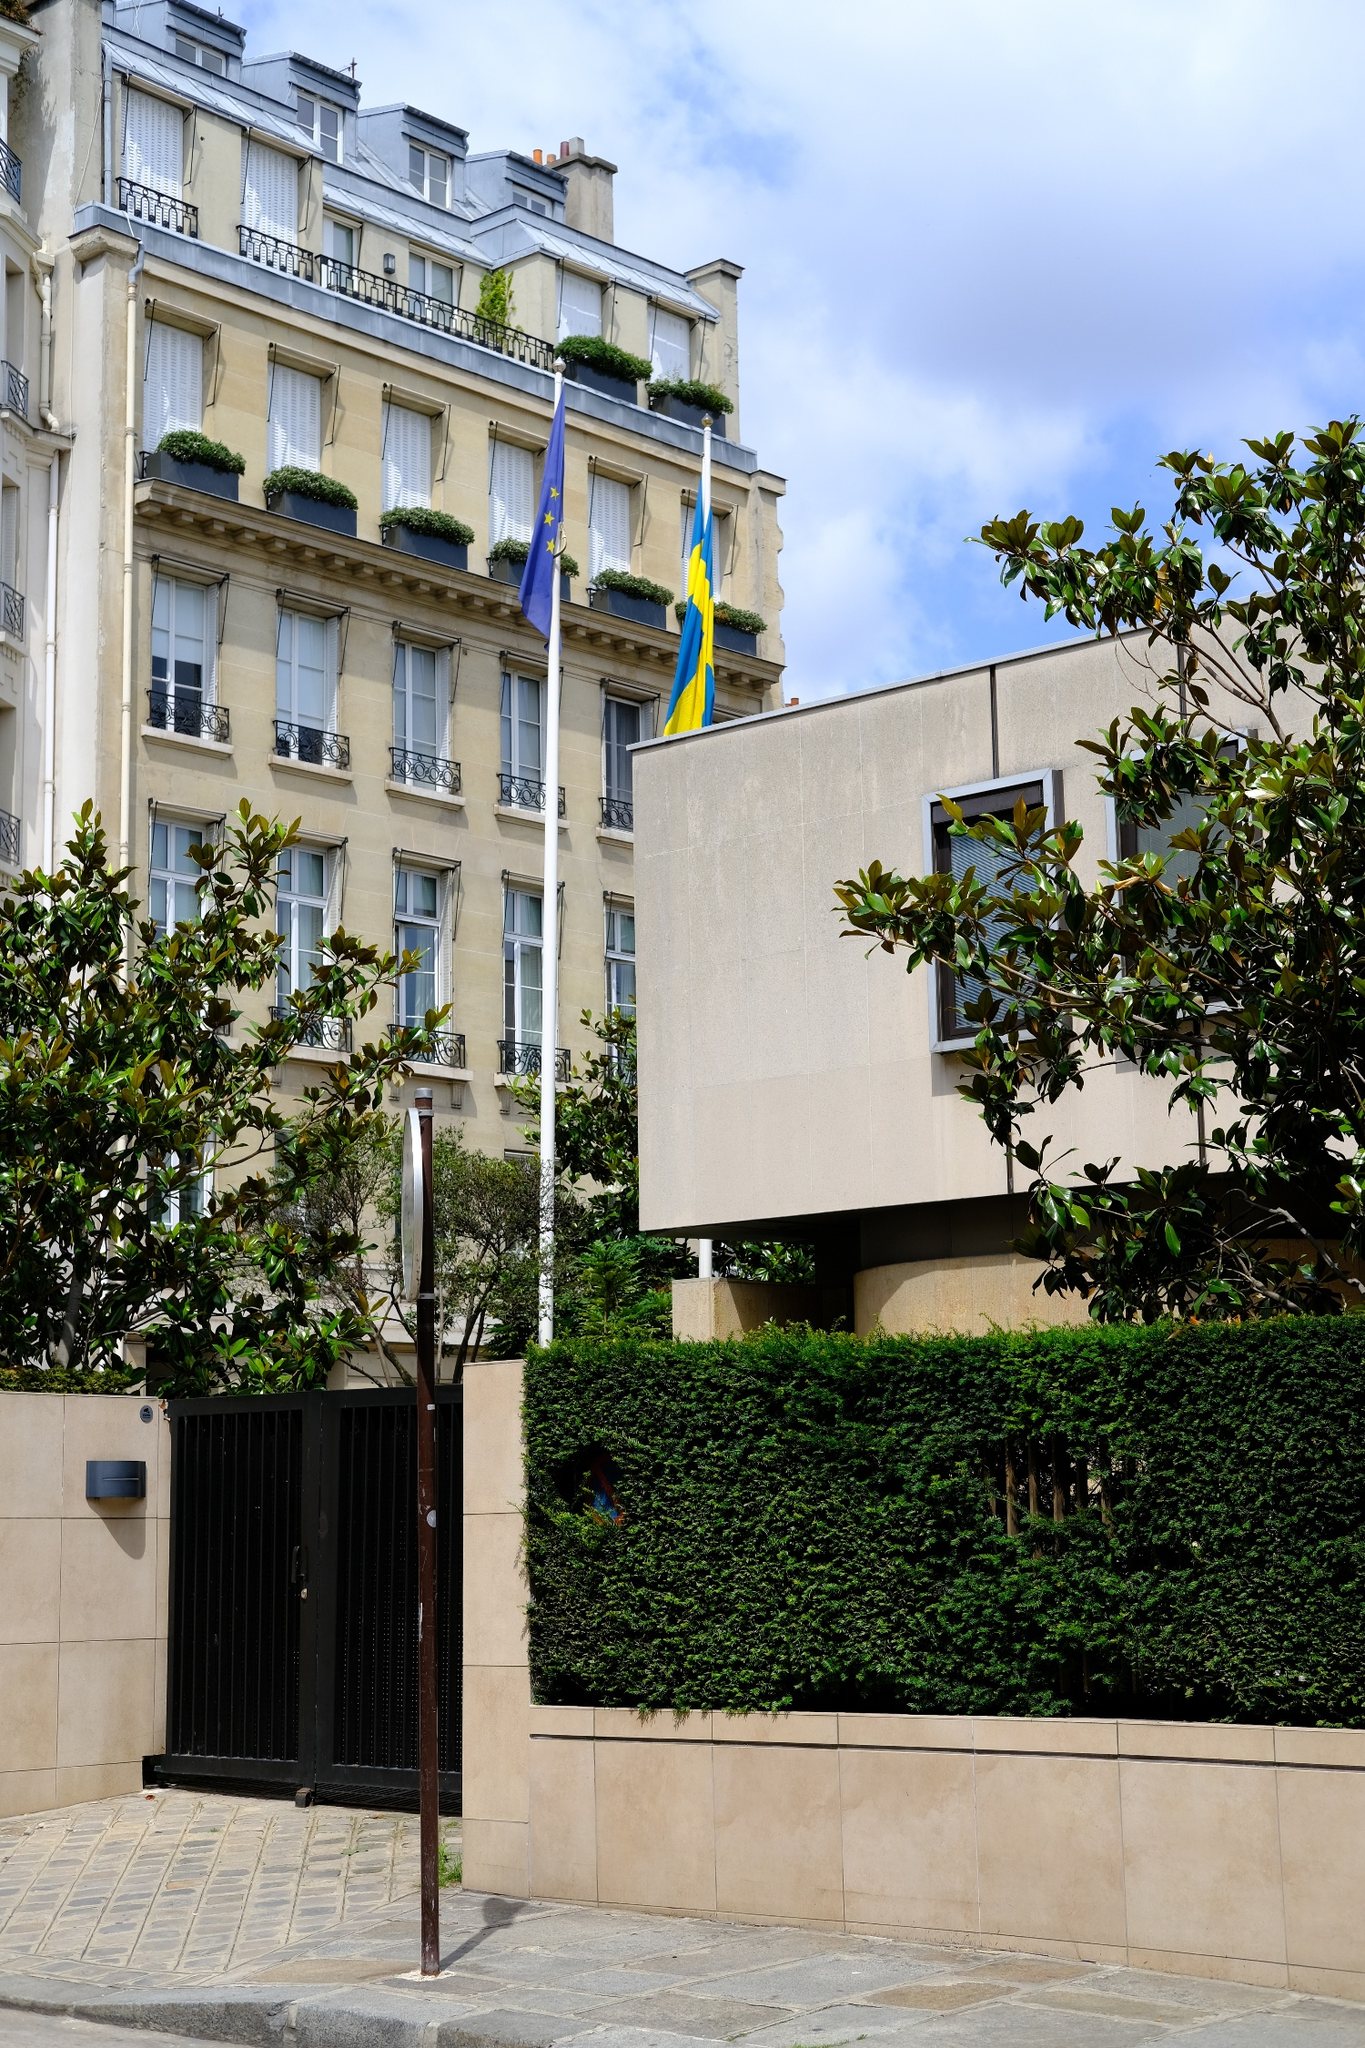Based on the greenery and architectural cues, what’s the ambiance of the surrounding area? The ambiance of the surrounding area emanates a blend of tranquility and sophistication. The lush greenery suggests a serene environment, with trees providing a natural respite amidst the urban setting. The classical architectural cues complement the calm, cultivated vibe, evoking a sense of timeless elegance. This seems to be a well-maintained area frequented by professionals, diplomats, and residents who enjoy the finer aspects of urban living. 